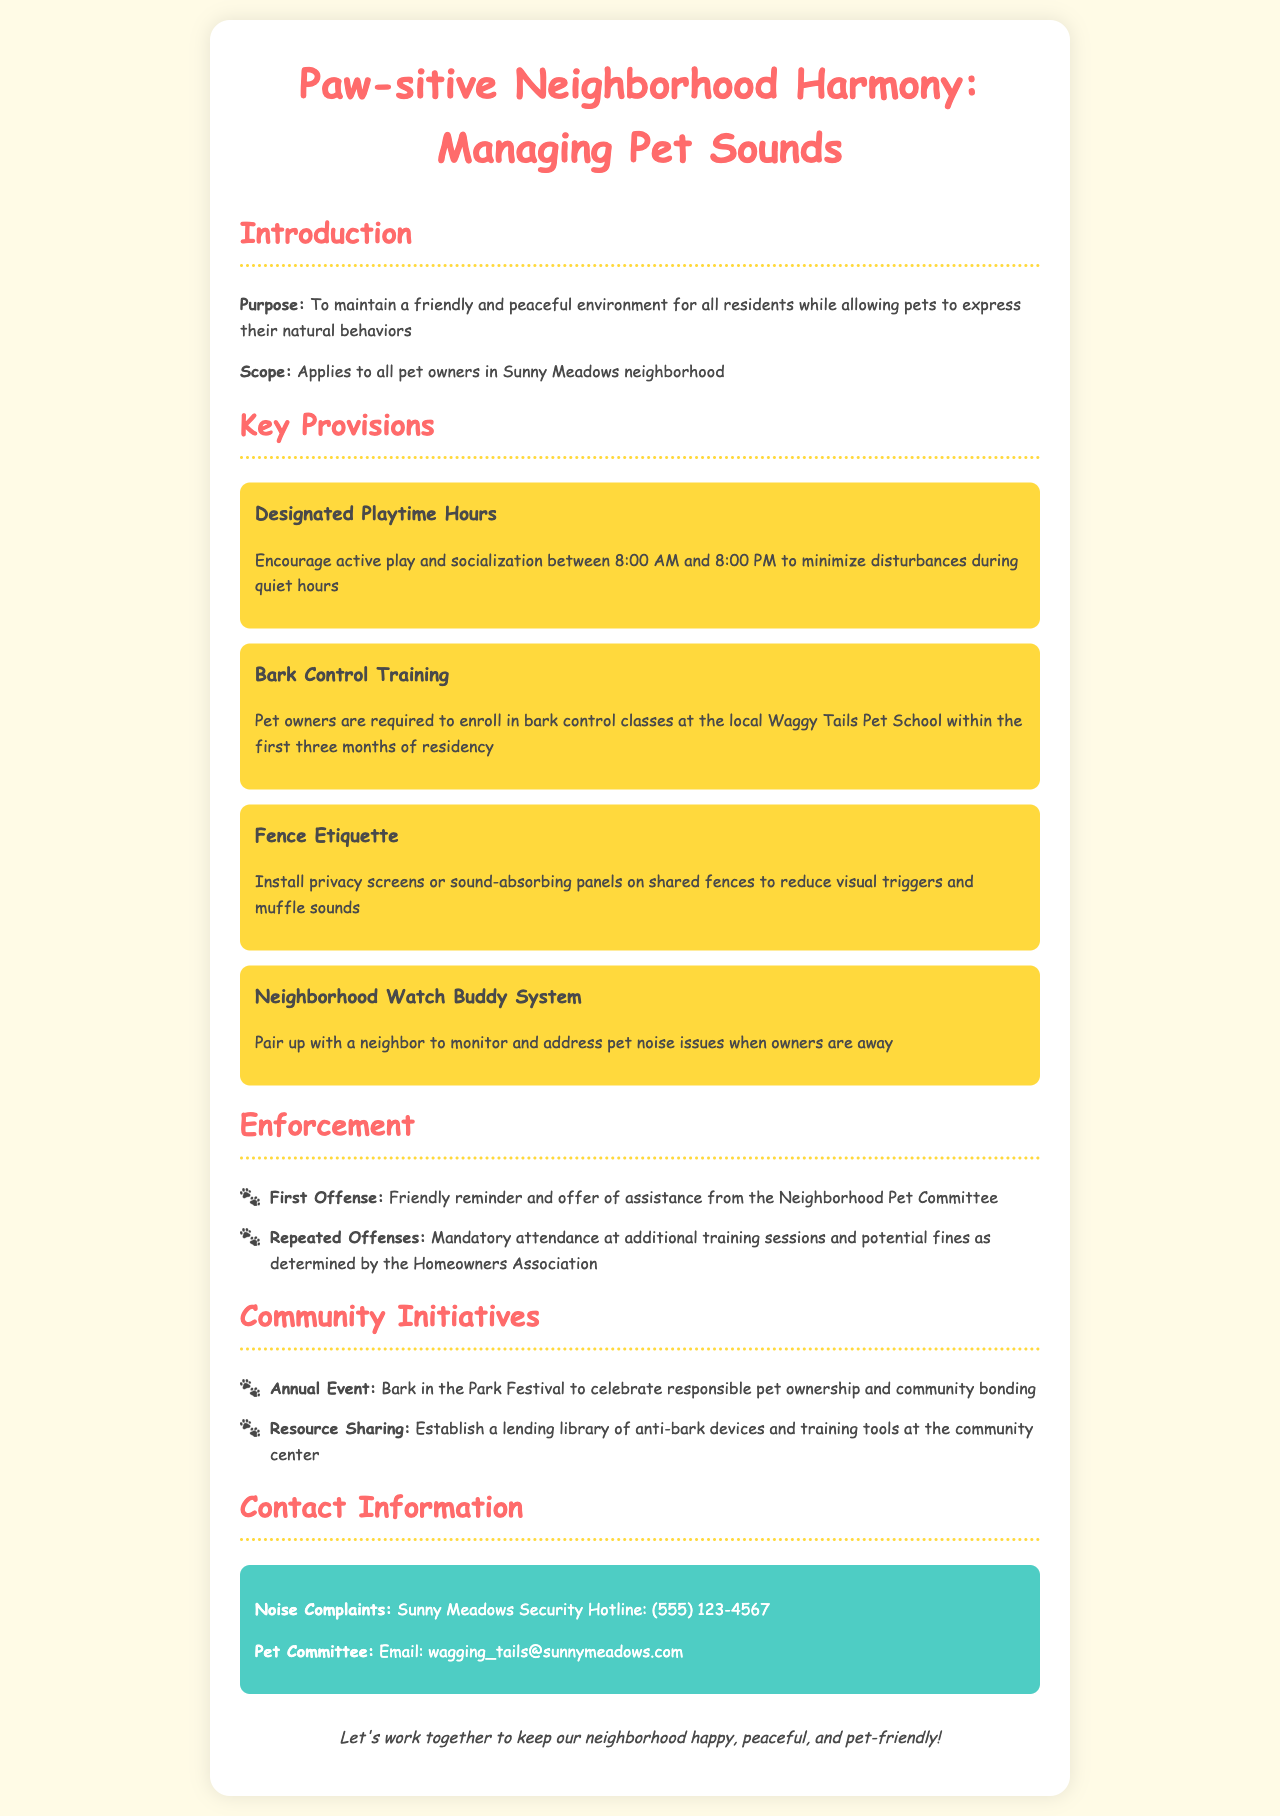What are the designated playtime hours? The designated playtime hours are specified to encourage active play and socialization during a set timeframe to minimize disturbances.
Answer: 8:00 AM to 8:00 PM What is required within the first three months of residency? The document states that pet owners must enroll in training to manage barking at a local pet school during a specified timeline after moving in.
Answer: Bark control classes What system is suggested for monitoring pet noise issues? The document outlines a community engagement strategy to help address noise complaints, which enhances neighborly cooperation.
Answer: Neighborhood Watch Buddy System What type of training session is mandated for repeated offenses? The policy indicates that upon repeated infractions, there are specific educational requirements to help pet owners improve their pet management.
Answer: Additional training sessions What is featured at the annual community event? The event aims to promote positive pet ownership and strengthen community ties, showcasing social aspects in a festive setting.
Answer: Bark in the Park Festival 